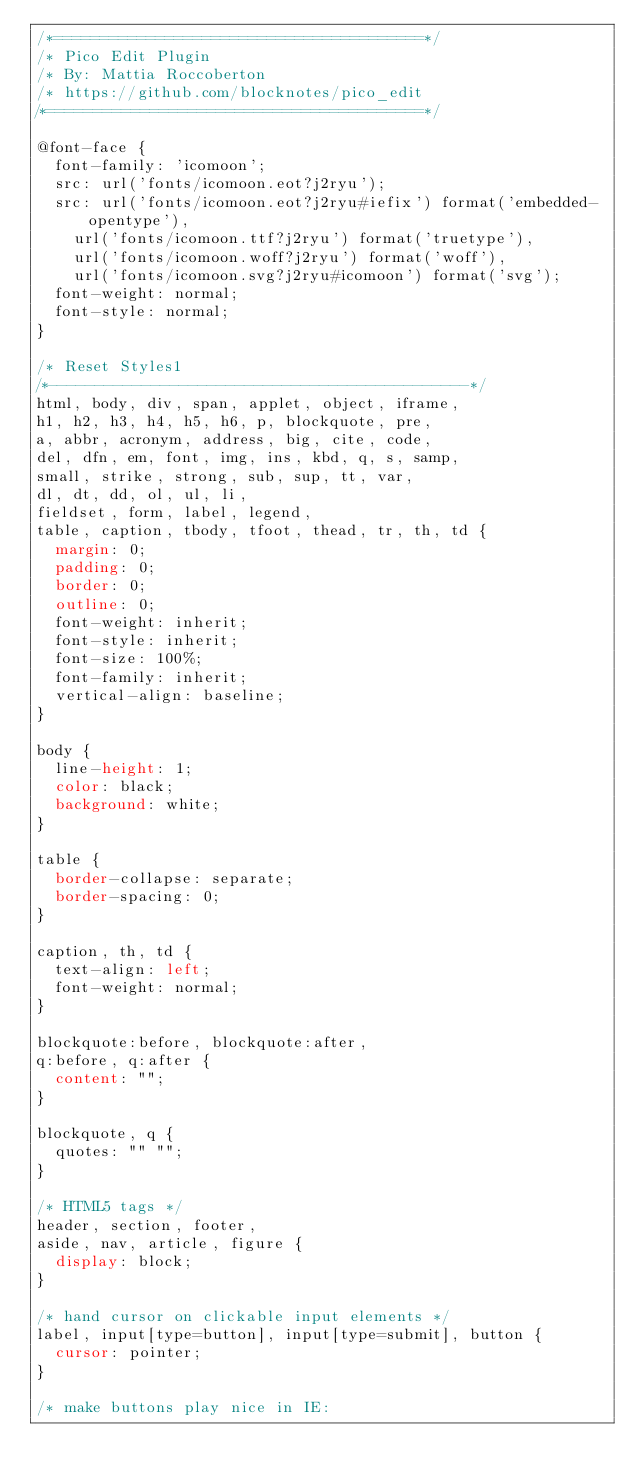<code> <loc_0><loc_0><loc_500><loc_500><_CSS_>/*========================================*/
/* Pico Edit Plugin
/* By: Mattia Roccoberton
/* https://github.com/blocknotes/pico_edit
/*========================================*/

@font-face {
  font-family: 'icomoon';
  src: url('fonts/icomoon.eot?j2ryu');
  src: url('fonts/icomoon.eot?j2ryu#iefix') format('embedded-opentype'),
    url('fonts/icomoon.ttf?j2ryu') format('truetype'),
    url('fonts/icomoon.woff?j2ryu') format('woff'),
    url('fonts/icomoon.svg?j2ryu#icomoon') format('svg');
  font-weight: normal;
  font-style: normal;
}

/* Reset Styles1
/*---------------------------------------------*/
html, body, div, span, applet, object, iframe,
h1, h2, h3, h4, h5, h6, p, blockquote, pre,
a, abbr, acronym, address, big, cite, code,
del, dfn, em, font, img, ins, kbd, q, s, samp,
small, strike, strong, sub, sup, tt, var,
dl, dt, dd, ol, ul, li,
fieldset, form, label, legend,
table, caption, tbody, tfoot, thead, tr, th, td {
  margin: 0;
  padding: 0;
  border: 0;
  outline: 0;
  font-weight: inherit;
  font-style: inherit;
  font-size: 100%;
  font-family: inherit;
  vertical-align: baseline;
}

body {
  line-height: 1;
  color: black;
  background: white;
}

table {
  border-collapse: separate;
  border-spacing: 0;
}

caption, th, td {
  text-align: left;
  font-weight: normal;
}

blockquote:before, blockquote:after,
q:before, q:after {
  content: "";
}

blockquote, q {
  quotes: "" "";
}

/* HTML5 tags */
header, section, footer,
aside, nav, article, figure {
  display: block;
}

/* hand cursor on clickable input elements */
label, input[type=button], input[type=submit], button {
  cursor: pointer;
}

/* make buttons play nice in IE:   </code> 